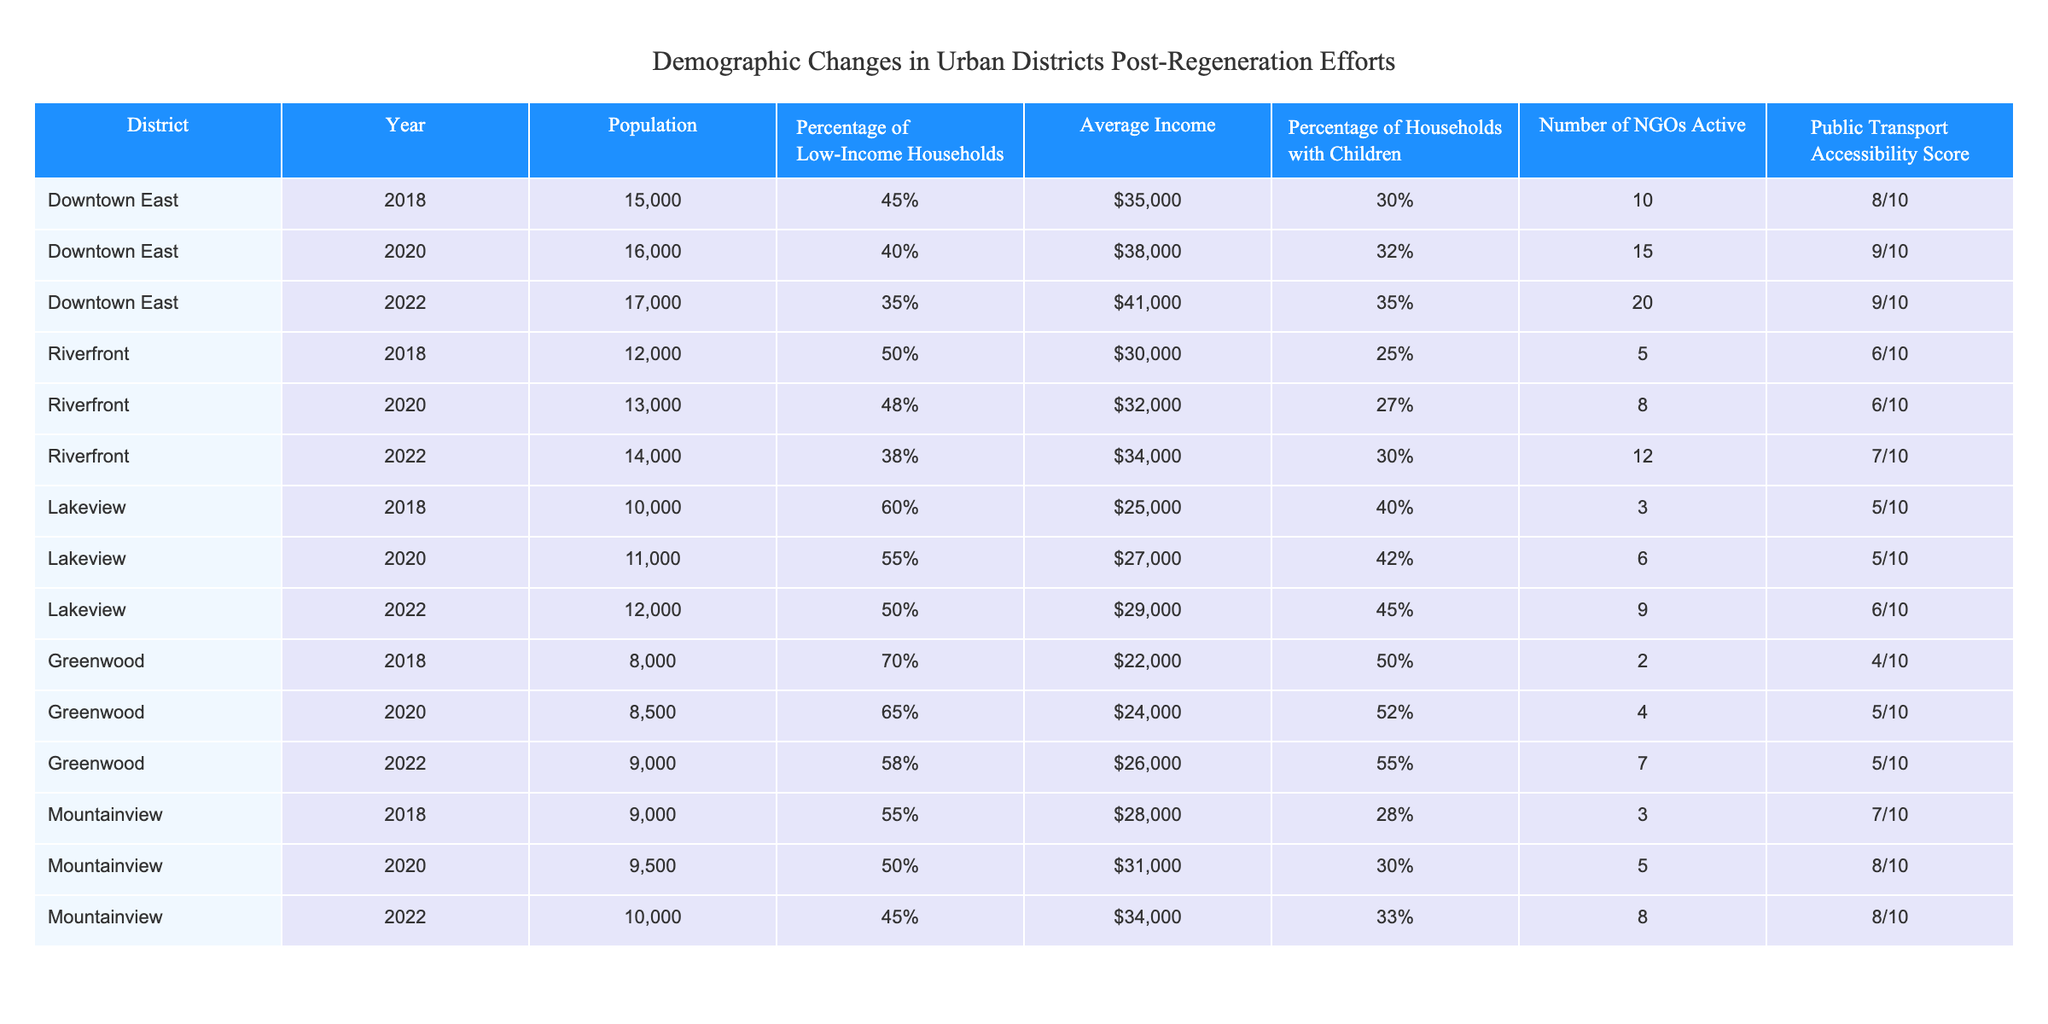What was the population of Downtown East in 2020? The table shows that the population of Downtown East in 2020 is listed as 16,000.
Answer: 16,000 What is the average income in the Riverfront district in 2022? According to the table, the average income in the Riverfront district for the year 2022 is $34,000.
Answer: $34,000 How many NGOs were active in Lakeview in 2020? The table indicates that there were 6 NGOs active in Lakeview in 2020.
Answer: 6 In which district was the percentage of low-income households the highest in 2018? The table shows that Greenwood had the highest percentage of low-income households at 70% in 2018.
Answer: Greenwood What is the percentage of households with children in Mountainview in 2022? The table reveals that in Mountainview, the percentage of households with children in 2022 is 33%.
Answer: 33% How much has the population increased in Downtown East from 2018 to 2022? The population in Downtown East increased from 15,000 in 2018 to 17,000 in 2022. Therefore, the increase is 17,000 - 15,000 = 2,000.
Answer: 2,000 Is there a direct correlation between the number of active NGOs and the percentage of low-income households across the districts? Looking at the table, for instance, Downtown East saw an increase in NGOs while decreasing the percentage of low-income households; similarly, Greenwood had a decrease in NGOs and a high percentage of low-income households. Thus, there is no clear direct correlation.
Answer: No What is the average public transport accessibility score for all districts in 2022? The public transport accessibility scores for different districts in 2022 are 9 (Downtown East), 7 (Riverfront), 6 (Lakeview), 5 (Greenwood), and 8 (Mountainview). The average score is (9 + 7 + 6 + 5 + 8)/5 = 7.
Answer: 7 Which district showed the highest public transport accessibility score in 2022? The table indicates that Downtown East had the highest public transport accessibility score of 9 in 2022.
Answer: Downtown East What is the change in the percentage of low-income households in Lakeview from 2018 to 2022? Lakeview had 60% low-income households in 2018 and 50% in 2022, resulting in a change of 60% - 50% = 10% decrease.
Answer: 10% decrease 